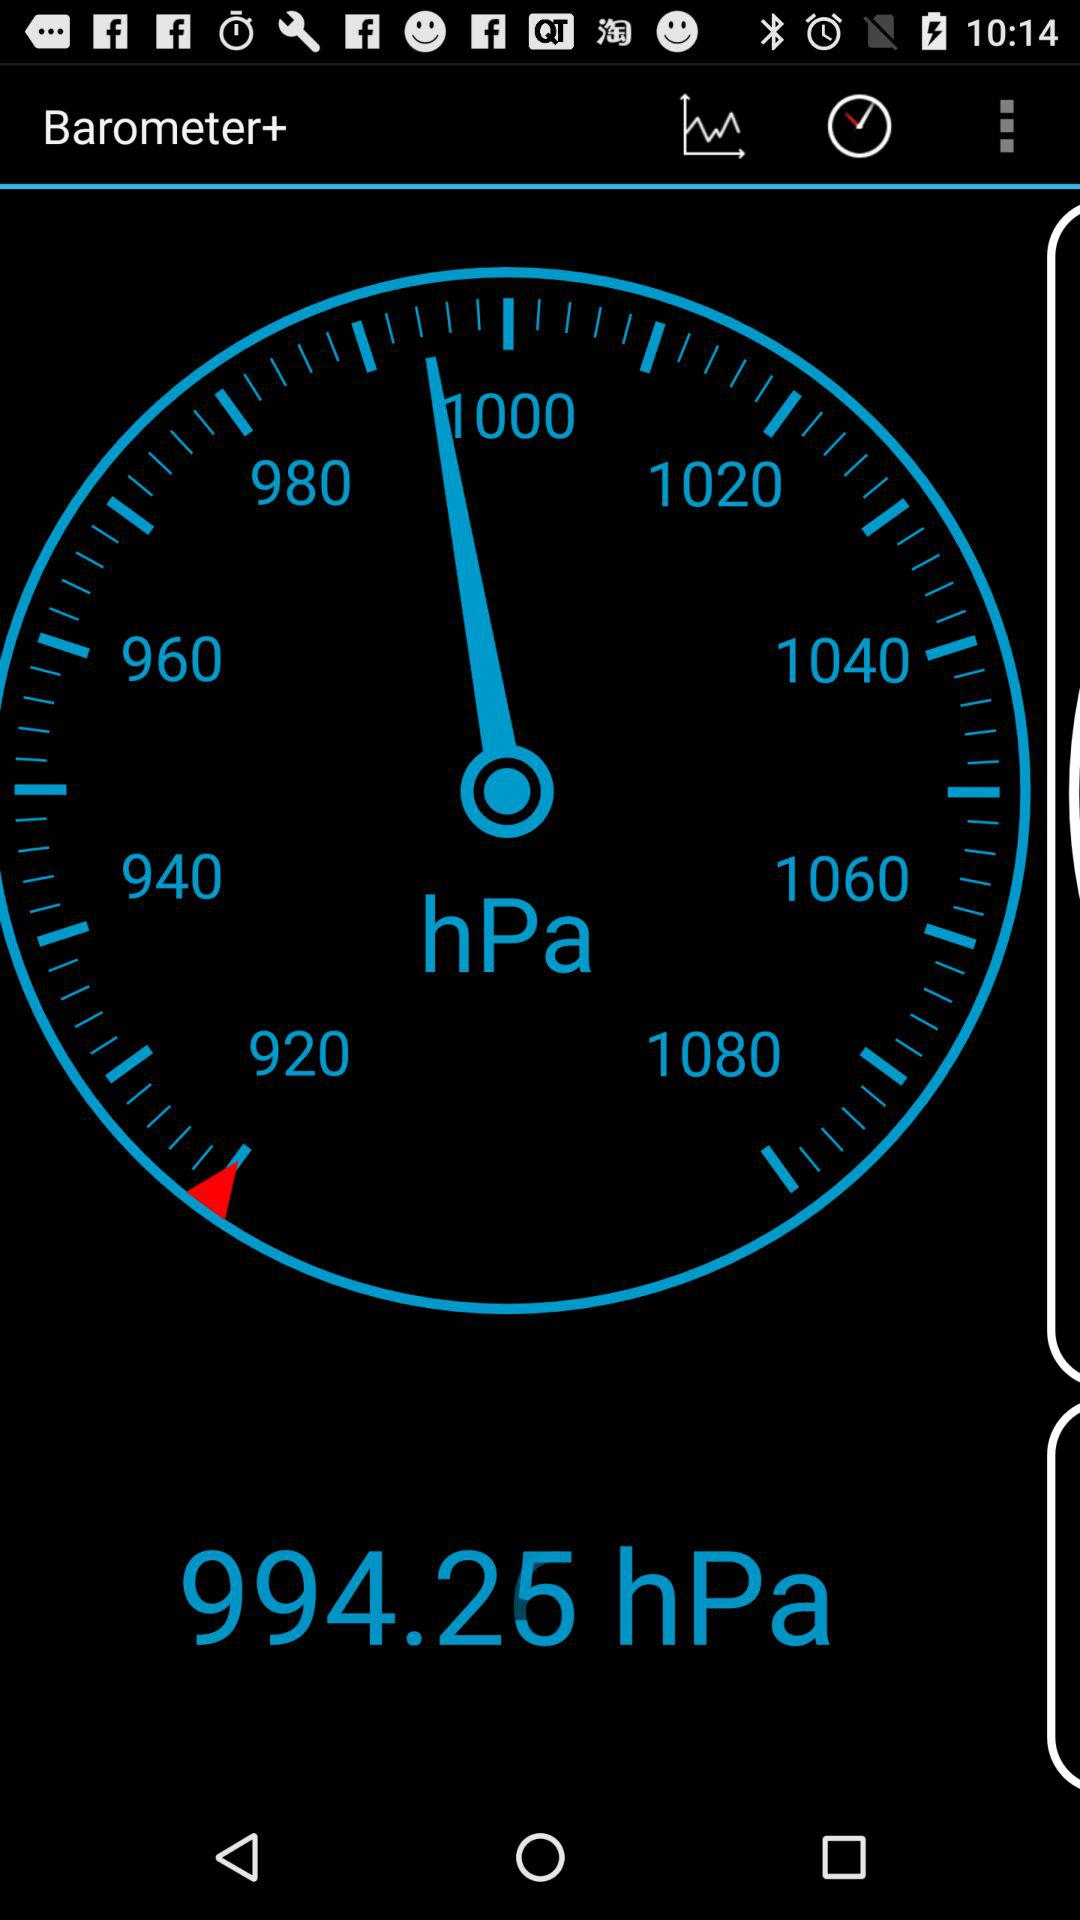What is the current barometric pressure?
Answer the question using a single word or phrase. 994.25 hPa 